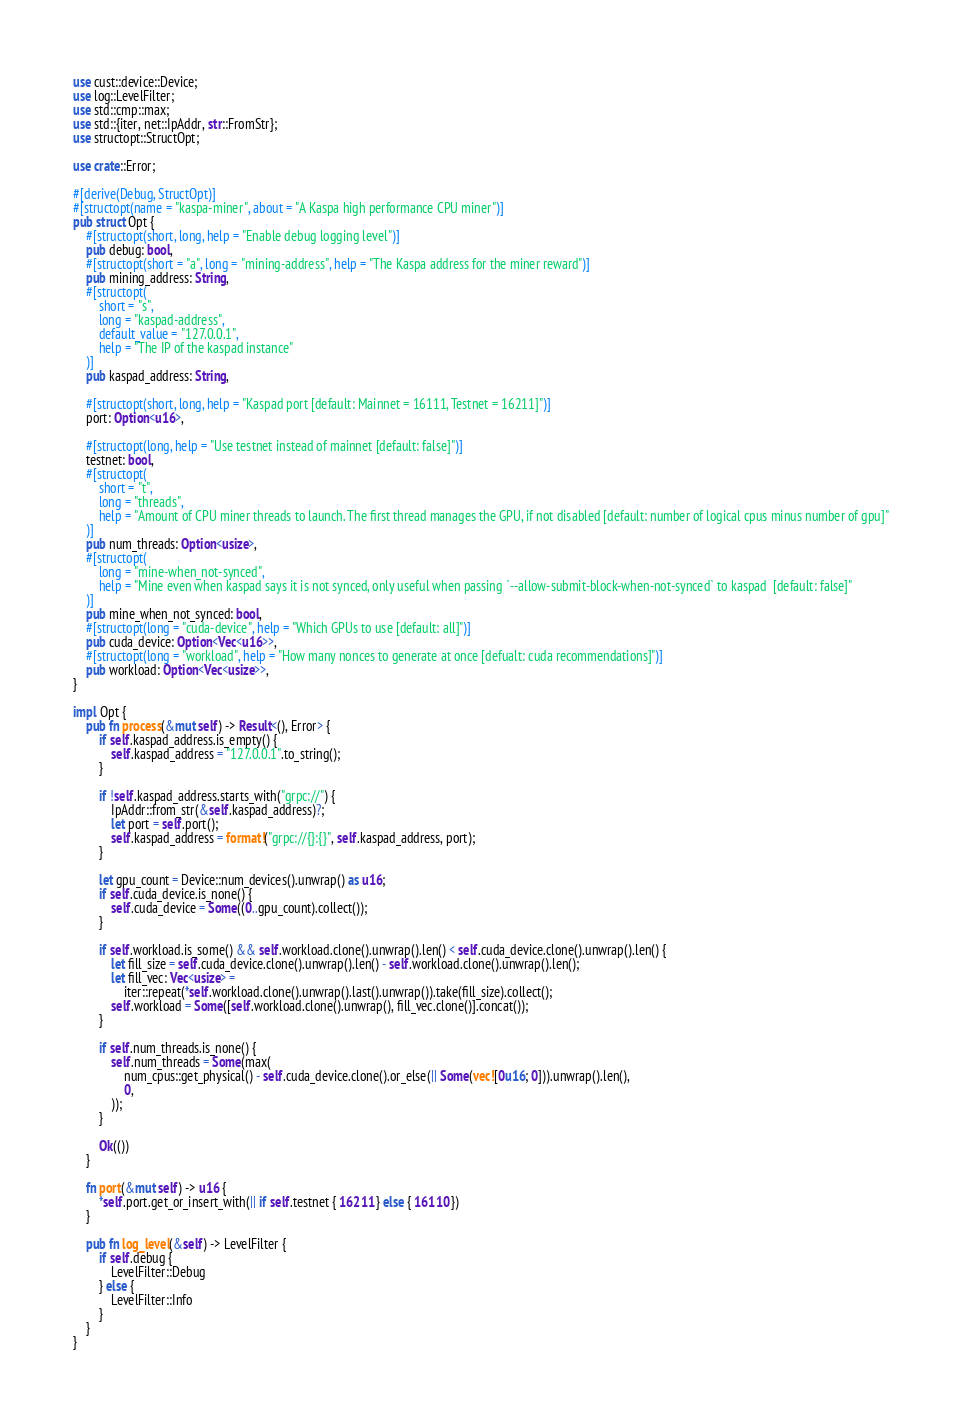<code> <loc_0><loc_0><loc_500><loc_500><_Rust_>use cust::device::Device;
use log::LevelFilter;
use std::cmp::max;
use std::{iter, net::IpAddr, str::FromStr};
use structopt::StructOpt;

use crate::Error;

#[derive(Debug, StructOpt)]
#[structopt(name = "kaspa-miner", about = "A Kaspa high performance CPU miner")]
pub struct Opt {
    #[structopt(short, long, help = "Enable debug logging level")]
    pub debug: bool,
    #[structopt(short = "a", long = "mining-address", help = "The Kaspa address for the miner reward")]
    pub mining_address: String,
    #[structopt(
        short = "s",
        long = "kaspad-address",
        default_value = "127.0.0.1",
        help = "The IP of the kaspad instance"
    )]
    pub kaspad_address: String,

    #[structopt(short, long, help = "Kaspad port [default: Mainnet = 16111, Testnet = 16211]")]
    port: Option<u16>,

    #[structopt(long, help = "Use testnet instead of mainnet [default: false]")]
    testnet: bool,
    #[structopt(
        short = "t",
        long = "threads",
        help = "Amount of CPU miner threads to launch. The first thread manages the GPU, if not disabled [default: number of logical cpus minus number of gpu]"
    )]
    pub num_threads: Option<usize>,
    #[structopt(
        long = "mine-when_not-synced",
        help = "Mine even when kaspad says it is not synced, only useful when passing `--allow-submit-block-when-not-synced` to kaspad  [default: false]"
    )]
    pub mine_when_not_synced: bool,
    #[structopt(long = "cuda-device", help = "Which GPUs to use [default: all]")]
    pub cuda_device: Option<Vec<u16>>,
    #[structopt(long = "workload", help = "How many nonces to generate at once [defualt: cuda recommendations]")]
    pub workload: Option<Vec<usize>>,
}

impl Opt {
    pub fn process(&mut self) -> Result<(), Error> {
        if self.kaspad_address.is_empty() {
            self.kaspad_address = "127.0.0.1".to_string();
        }

        if !self.kaspad_address.starts_with("grpc://") {
            IpAddr::from_str(&self.kaspad_address)?;
            let port = self.port();
            self.kaspad_address = format!("grpc://{}:{}", self.kaspad_address, port);
        }

        let gpu_count = Device::num_devices().unwrap() as u16;
        if self.cuda_device.is_none() {
            self.cuda_device = Some((0..gpu_count).collect());
        }

        if self.workload.is_some() && self.workload.clone().unwrap().len() < self.cuda_device.clone().unwrap().len() {
            let fill_size = self.cuda_device.clone().unwrap().len() - self.workload.clone().unwrap().len();
            let fill_vec: Vec<usize> =
                iter::repeat(*self.workload.clone().unwrap().last().unwrap()).take(fill_size).collect();
            self.workload = Some([self.workload.clone().unwrap(), fill_vec.clone()].concat());
        }

        if self.num_threads.is_none() {
            self.num_threads = Some(max(
                num_cpus::get_physical() - self.cuda_device.clone().or_else(|| Some(vec![0u16; 0])).unwrap().len(),
                0,
            ));
        }

        Ok(())
    }

    fn port(&mut self) -> u16 {
        *self.port.get_or_insert_with(|| if self.testnet { 16211 } else { 16110 })
    }

    pub fn log_level(&self) -> LevelFilter {
        if self.debug {
            LevelFilter::Debug
        } else {
            LevelFilter::Info
        }
    }
}
</code> 